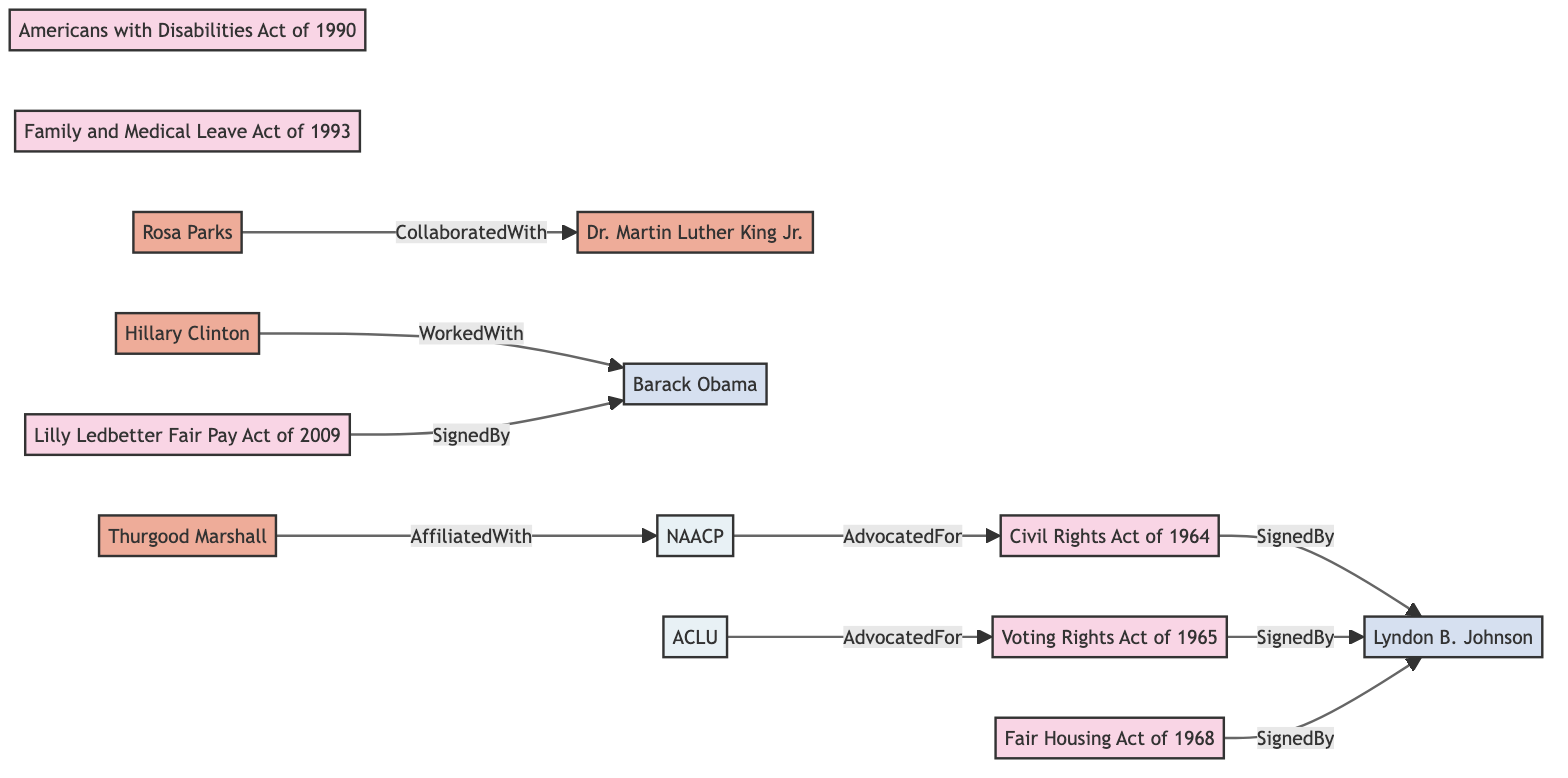What legislation was signed by Lyndon B. Johnson? The diagram shows that three acts were signed by Lyndon B. Johnson: Civil Rights Act of 1964, Voting Rights Act of 1965, and Fair Housing Act of 1968. Therefore, one can find these acts connected to Lyndon B. Johnson through the "SignedBy" relationship.
Answer: Civil Rights Act of 1964, Voting Rights Act of 1965, Fair Housing Act of 1968 Who collaborated with Rosa Parks? The diagram indicates that Rosa Parks is connected to Dr. Martin Luther King Jr. through the "CollaboratedWith" relationship. Therefore, by identifying this connection, we can determine the individual she collaborated with.
Answer: Dr. Martin Luther King Jr How many organizations are mentioned in the diagram? The diagram lists two organizations: NAACP and ACLU. By counting these nodes, we establish how many organizations are represented.
Answer: 2 Which president signed the Lilly Ledbetter Fair Pay Act? The "SignedBy" relationship linked with Lilly Ledbetter Fair Pay Act indicates that Barack Obama was responsible for signing this act. Thus, one can see from the diagram the name associated with this act.
Answer: Barack Obama Which key stakeholder is affiliated with the NAACP? The diagram highlights that Thurgood Marshall is connected to the NAACP through the "AffiliatedWith" relationship. By following this edge, we can associate the individual with the organization mentioned.
Answer: Thurgood Marshall Who worked with Barack Obama in the diagram? The link between Hillary Clinton and Barack Obama, labeled "WorkedWith", indicates that Hillary Clinton is the individual who has a working relationship with Barack Obama. Hence, we identify the stakeholder based on this relationship.
Answer: Hillary Clinton What is the relationship between the NAACP and the Civil Rights Act of 1964? The diagram shows a direct connection from the NAACP to the Civil Rights Act of 1964 labeled "AdvocatedFor". This relationship signifies that the NAACP advocated for the passage of the Civil Rights Act of 1964, allowing us to determine the type of connection present.
Answer: AdvocatedFor How many total nodes are present in the diagram? Counting all unique nodes in the diagram, including legislations, stakeholders, presidents, and organizations, reveals the total number of nodes. Each category contributes to the overall total.
Answer: 14 